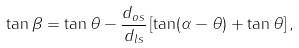Convert formula to latex. <formula><loc_0><loc_0><loc_500><loc_500>\tan \beta = \tan \theta - \frac { d _ { o s } } { d _ { l s } } \left [ \tan ( \alpha - \theta ) + \tan \theta \right ] ,</formula> 